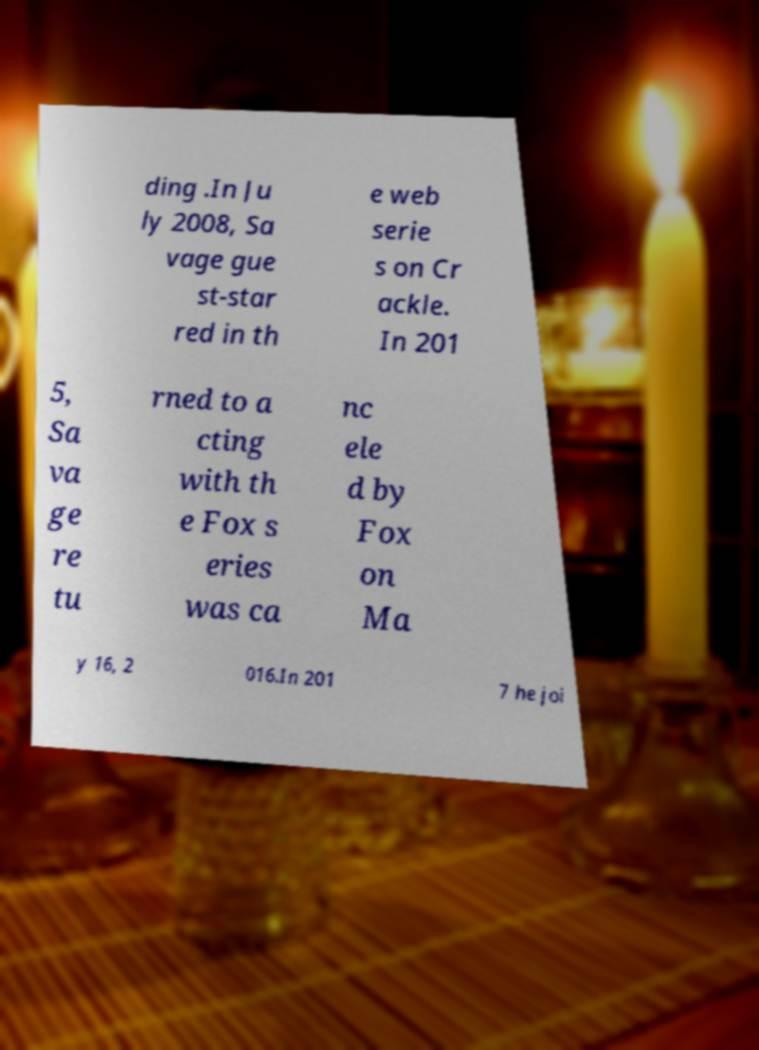There's text embedded in this image that I need extracted. Can you transcribe it verbatim? ding .In Ju ly 2008, Sa vage gue st-star red in th e web serie s on Cr ackle. In 201 5, Sa va ge re tu rned to a cting with th e Fox s eries was ca nc ele d by Fox on Ma y 16, 2 016.In 201 7 he joi 